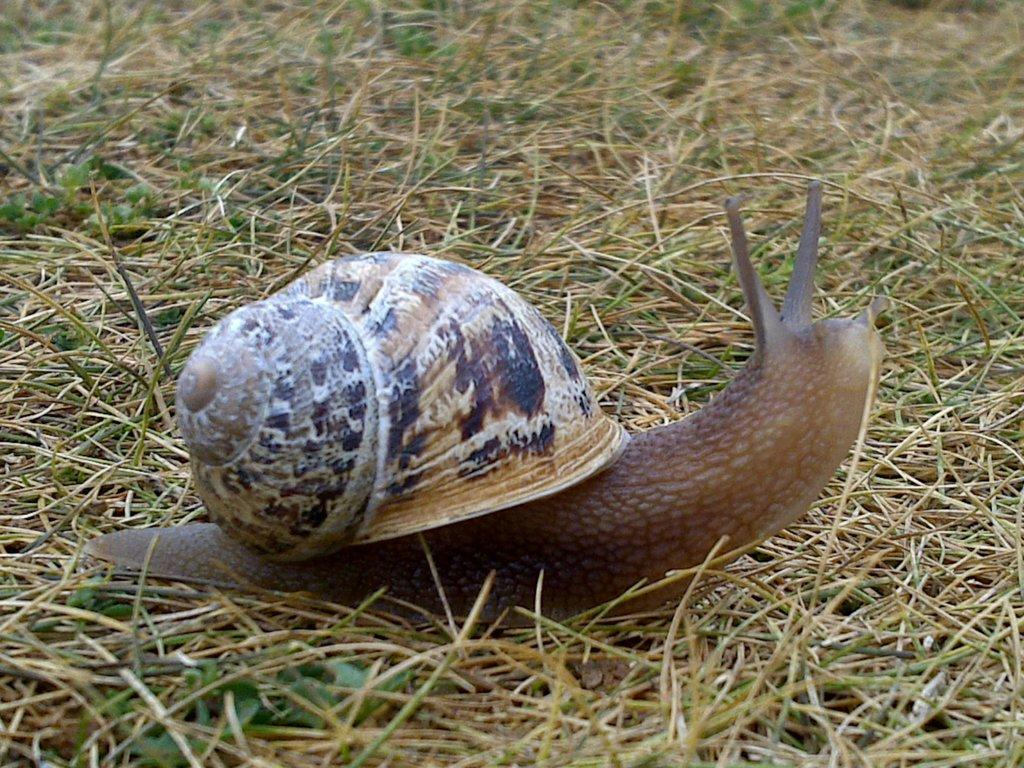What type of animal can be seen in the image? There is a snail in the image. What is the environment like in the image? There is a grassy land in the image. How many kittens are playing with the snail in the image? There are no kittens present in the image; it only features a snail on a grassy land. 